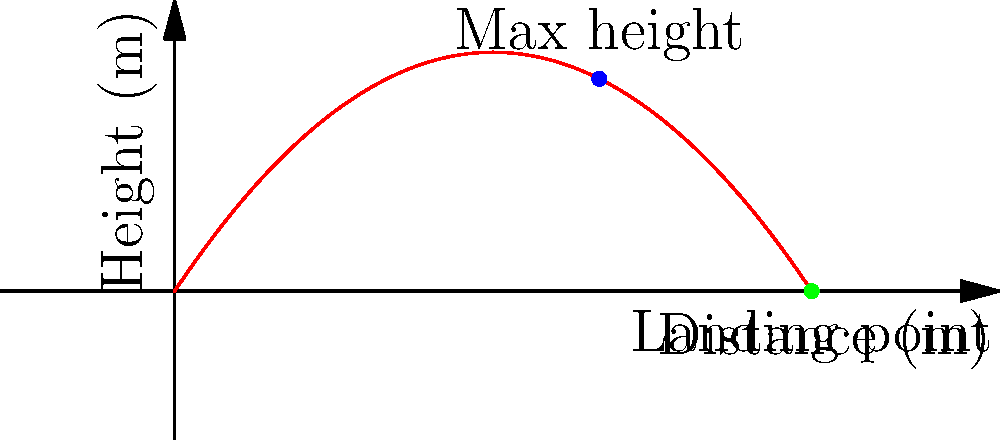Analyze the graph representing the trajectory of a soccer ball kick. What is the approximate distance the ball travels before hitting the ground? To determine the distance the ball travels before hitting the ground, we need to follow these steps:

1. Understand the graph:
   - The x-axis represents the horizontal distance traveled.
   - The y-axis represents the height of the ball.
   - The curve shows the trajectory of the ball.

2. Identify key points:
   - The ball starts at the origin (0,0).
   - The highest point (apex) is labeled "Max height".
   - The end point where the ball lands is labeled "Landing point".

3. Analyze the landing point:
   - The landing point is where the curve intersects the x-axis.
   - This point represents where the height (y) becomes zero.

4. Read the x-coordinate of the landing point:
   - The x-coordinate of the landing point is approximately 30 meters.

5. Interpret the result:
   - The x-coordinate of the landing point represents the total horizontal distance traveled by the ball.

Therefore, the ball travels approximately 30 meters before hitting the ground.
Answer: 30 meters 